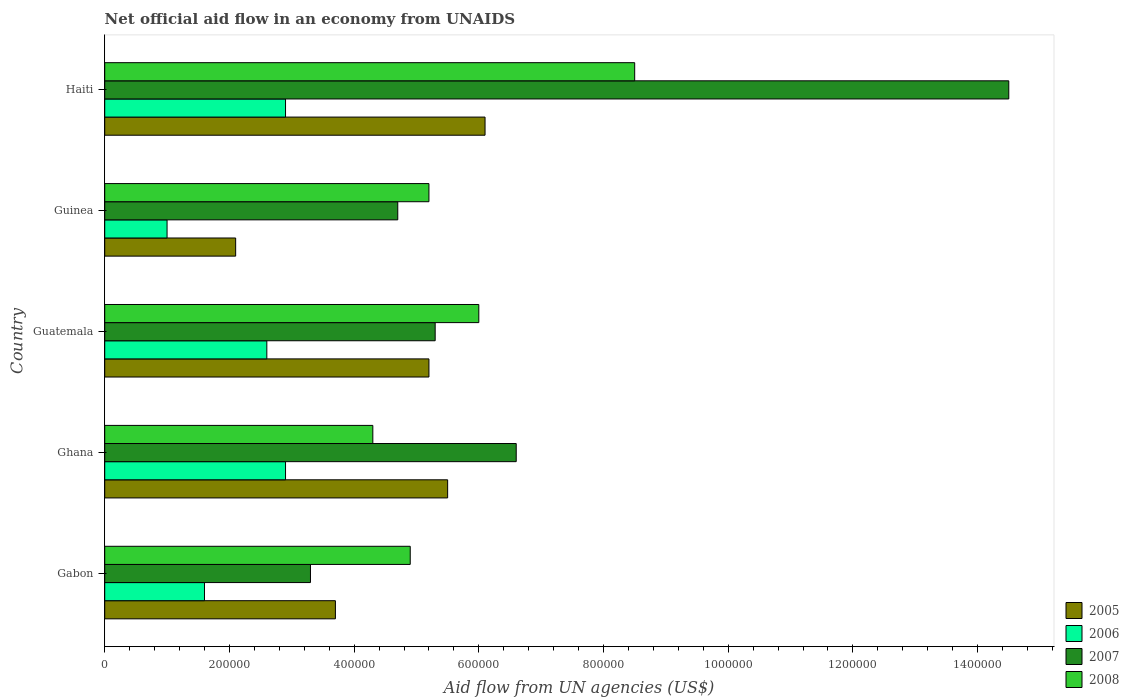Are the number of bars per tick equal to the number of legend labels?
Give a very brief answer. Yes. Are the number of bars on each tick of the Y-axis equal?
Make the answer very short. Yes. How many bars are there on the 4th tick from the bottom?
Your answer should be compact. 4. Across all countries, what is the maximum net official aid flow in 2008?
Give a very brief answer. 8.50e+05. In which country was the net official aid flow in 2005 maximum?
Provide a succinct answer. Haiti. In which country was the net official aid flow in 2006 minimum?
Your answer should be compact. Guinea. What is the total net official aid flow in 2007 in the graph?
Your response must be concise. 3.44e+06. What is the average net official aid flow in 2008 per country?
Give a very brief answer. 5.78e+05. What is the difference between the net official aid flow in 2008 and net official aid flow in 2007 in Haiti?
Your answer should be compact. -6.00e+05. What is the ratio of the net official aid flow in 2008 in Gabon to that in Guatemala?
Provide a short and direct response. 0.82. What is the difference between the highest and the second highest net official aid flow in 2008?
Your answer should be very brief. 2.50e+05. What is the difference between the highest and the lowest net official aid flow in 2006?
Your answer should be compact. 1.90e+05. In how many countries, is the net official aid flow in 2005 greater than the average net official aid flow in 2005 taken over all countries?
Offer a terse response. 3. Is the sum of the net official aid flow in 2005 in Ghana and Guinea greater than the maximum net official aid flow in 2006 across all countries?
Offer a very short reply. Yes. Is it the case that in every country, the sum of the net official aid flow in 2005 and net official aid flow in 2007 is greater than the sum of net official aid flow in 2008 and net official aid flow in 2006?
Offer a terse response. No. What does the 2nd bar from the top in Haiti represents?
Provide a succinct answer. 2007. Is it the case that in every country, the sum of the net official aid flow in 2007 and net official aid flow in 2005 is greater than the net official aid flow in 2008?
Give a very brief answer. Yes. How many bars are there?
Give a very brief answer. 20. Are all the bars in the graph horizontal?
Your response must be concise. Yes. How many countries are there in the graph?
Provide a succinct answer. 5. What is the difference between two consecutive major ticks on the X-axis?
Give a very brief answer. 2.00e+05. Where does the legend appear in the graph?
Your response must be concise. Bottom right. What is the title of the graph?
Make the answer very short. Net official aid flow in an economy from UNAIDS. What is the label or title of the X-axis?
Your response must be concise. Aid flow from UN agencies (US$). What is the Aid flow from UN agencies (US$) in 2005 in Gabon?
Your response must be concise. 3.70e+05. What is the Aid flow from UN agencies (US$) of 2006 in Gabon?
Provide a succinct answer. 1.60e+05. What is the Aid flow from UN agencies (US$) of 2008 in Gabon?
Offer a very short reply. 4.90e+05. What is the Aid flow from UN agencies (US$) in 2005 in Guatemala?
Give a very brief answer. 5.20e+05. What is the Aid flow from UN agencies (US$) in 2007 in Guatemala?
Your answer should be very brief. 5.30e+05. What is the Aid flow from UN agencies (US$) of 2008 in Guatemala?
Give a very brief answer. 6.00e+05. What is the Aid flow from UN agencies (US$) of 2008 in Guinea?
Provide a short and direct response. 5.20e+05. What is the Aid flow from UN agencies (US$) of 2006 in Haiti?
Provide a succinct answer. 2.90e+05. What is the Aid flow from UN agencies (US$) in 2007 in Haiti?
Keep it short and to the point. 1.45e+06. What is the Aid flow from UN agencies (US$) of 2008 in Haiti?
Offer a terse response. 8.50e+05. Across all countries, what is the maximum Aid flow from UN agencies (US$) of 2005?
Provide a succinct answer. 6.10e+05. Across all countries, what is the maximum Aid flow from UN agencies (US$) of 2006?
Your answer should be very brief. 2.90e+05. Across all countries, what is the maximum Aid flow from UN agencies (US$) in 2007?
Your answer should be very brief. 1.45e+06. Across all countries, what is the maximum Aid flow from UN agencies (US$) in 2008?
Your answer should be very brief. 8.50e+05. Across all countries, what is the minimum Aid flow from UN agencies (US$) of 2006?
Provide a succinct answer. 1.00e+05. Across all countries, what is the minimum Aid flow from UN agencies (US$) in 2007?
Offer a terse response. 3.30e+05. What is the total Aid flow from UN agencies (US$) of 2005 in the graph?
Make the answer very short. 2.26e+06. What is the total Aid flow from UN agencies (US$) in 2006 in the graph?
Provide a short and direct response. 1.10e+06. What is the total Aid flow from UN agencies (US$) of 2007 in the graph?
Give a very brief answer. 3.44e+06. What is the total Aid flow from UN agencies (US$) of 2008 in the graph?
Your answer should be very brief. 2.89e+06. What is the difference between the Aid flow from UN agencies (US$) in 2005 in Gabon and that in Ghana?
Offer a terse response. -1.80e+05. What is the difference between the Aid flow from UN agencies (US$) in 2006 in Gabon and that in Ghana?
Keep it short and to the point. -1.30e+05. What is the difference between the Aid flow from UN agencies (US$) of 2007 in Gabon and that in Ghana?
Ensure brevity in your answer.  -3.30e+05. What is the difference between the Aid flow from UN agencies (US$) in 2006 in Gabon and that in Guatemala?
Provide a short and direct response. -1.00e+05. What is the difference between the Aid flow from UN agencies (US$) in 2007 in Gabon and that in Guatemala?
Give a very brief answer. -2.00e+05. What is the difference between the Aid flow from UN agencies (US$) in 2008 in Gabon and that in Guatemala?
Give a very brief answer. -1.10e+05. What is the difference between the Aid flow from UN agencies (US$) of 2005 in Gabon and that in Haiti?
Give a very brief answer. -2.40e+05. What is the difference between the Aid flow from UN agencies (US$) of 2007 in Gabon and that in Haiti?
Offer a very short reply. -1.12e+06. What is the difference between the Aid flow from UN agencies (US$) in 2008 in Gabon and that in Haiti?
Keep it short and to the point. -3.60e+05. What is the difference between the Aid flow from UN agencies (US$) of 2005 in Ghana and that in Guatemala?
Make the answer very short. 3.00e+04. What is the difference between the Aid flow from UN agencies (US$) in 2007 in Ghana and that in Guatemala?
Your answer should be very brief. 1.30e+05. What is the difference between the Aid flow from UN agencies (US$) in 2005 in Ghana and that in Guinea?
Offer a very short reply. 3.40e+05. What is the difference between the Aid flow from UN agencies (US$) of 2008 in Ghana and that in Guinea?
Your answer should be compact. -9.00e+04. What is the difference between the Aid flow from UN agencies (US$) of 2006 in Ghana and that in Haiti?
Make the answer very short. 0. What is the difference between the Aid flow from UN agencies (US$) in 2007 in Ghana and that in Haiti?
Ensure brevity in your answer.  -7.90e+05. What is the difference between the Aid flow from UN agencies (US$) of 2008 in Ghana and that in Haiti?
Provide a short and direct response. -4.20e+05. What is the difference between the Aid flow from UN agencies (US$) in 2007 in Guatemala and that in Guinea?
Your answer should be compact. 6.00e+04. What is the difference between the Aid flow from UN agencies (US$) of 2007 in Guatemala and that in Haiti?
Offer a terse response. -9.20e+05. What is the difference between the Aid flow from UN agencies (US$) of 2008 in Guatemala and that in Haiti?
Keep it short and to the point. -2.50e+05. What is the difference between the Aid flow from UN agencies (US$) in 2005 in Guinea and that in Haiti?
Make the answer very short. -4.00e+05. What is the difference between the Aid flow from UN agencies (US$) in 2006 in Guinea and that in Haiti?
Ensure brevity in your answer.  -1.90e+05. What is the difference between the Aid flow from UN agencies (US$) of 2007 in Guinea and that in Haiti?
Provide a short and direct response. -9.80e+05. What is the difference between the Aid flow from UN agencies (US$) of 2008 in Guinea and that in Haiti?
Your answer should be compact. -3.30e+05. What is the difference between the Aid flow from UN agencies (US$) of 2006 in Gabon and the Aid flow from UN agencies (US$) of 2007 in Ghana?
Your response must be concise. -5.00e+05. What is the difference between the Aid flow from UN agencies (US$) in 2005 in Gabon and the Aid flow from UN agencies (US$) in 2007 in Guatemala?
Provide a short and direct response. -1.60e+05. What is the difference between the Aid flow from UN agencies (US$) in 2005 in Gabon and the Aid flow from UN agencies (US$) in 2008 in Guatemala?
Your answer should be compact. -2.30e+05. What is the difference between the Aid flow from UN agencies (US$) in 2006 in Gabon and the Aid flow from UN agencies (US$) in 2007 in Guatemala?
Ensure brevity in your answer.  -3.70e+05. What is the difference between the Aid flow from UN agencies (US$) of 2006 in Gabon and the Aid flow from UN agencies (US$) of 2008 in Guatemala?
Offer a terse response. -4.40e+05. What is the difference between the Aid flow from UN agencies (US$) of 2007 in Gabon and the Aid flow from UN agencies (US$) of 2008 in Guatemala?
Ensure brevity in your answer.  -2.70e+05. What is the difference between the Aid flow from UN agencies (US$) of 2005 in Gabon and the Aid flow from UN agencies (US$) of 2006 in Guinea?
Provide a short and direct response. 2.70e+05. What is the difference between the Aid flow from UN agencies (US$) of 2005 in Gabon and the Aid flow from UN agencies (US$) of 2008 in Guinea?
Keep it short and to the point. -1.50e+05. What is the difference between the Aid flow from UN agencies (US$) of 2006 in Gabon and the Aid flow from UN agencies (US$) of 2007 in Guinea?
Provide a short and direct response. -3.10e+05. What is the difference between the Aid flow from UN agencies (US$) in 2006 in Gabon and the Aid flow from UN agencies (US$) in 2008 in Guinea?
Ensure brevity in your answer.  -3.60e+05. What is the difference between the Aid flow from UN agencies (US$) of 2007 in Gabon and the Aid flow from UN agencies (US$) of 2008 in Guinea?
Your answer should be very brief. -1.90e+05. What is the difference between the Aid flow from UN agencies (US$) of 2005 in Gabon and the Aid flow from UN agencies (US$) of 2006 in Haiti?
Make the answer very short. 8.00e+04. What is the difference between the Aid flow from UN agencies (US$) in 2005 in Gabon and the Aid flow from UN agencies (US$) in 2007 in Haiti?
Provide a succinct answer. -1.08e+06. What is the difference between the Aid flow from UN agencies (US$) in 2005 in Gabon and the Aid flow from UN agencies (US$) in 2008 in Haiti?
Your answer should be compact. -4.80e+05. What is the difference between the Aid flow from UN agencies (US$) in 2006 in Gabon and the Aid flow from UN agencies (US$) in 2007 in Haiti?
Make the answer very short. -1.29e+06. What is the difference between the Aid flow from UN agencies (US$) of 2006 in Gabon and the Aid flow from UN agencies (US$) of 2008 in Haiti?
Offer a very short reply. -6.90e+05. What is the difference between the Aid flow from UN agencies (US$) in 2007 in Gabon and the Aid flow from UN agencies (US$) in 2008 in Haiti?
Your answer should be very brief. -5.20e+05. What is the difference between the Aid flow from UN agencies (US$) of 2005 in Ghana and the Aid flow from UN agencies (US$) of 2006 in Guatemala?
Ensure brevity in your answer.  2.90e+05. What is the difference between the Aid flow from UN agencies (US$) in 2006 in Ghana and the Aid flow from UN agencies (US$) in 2007 in Guatemala?
Keep it short and to the point. -2.40e+05. What is the difference between the Aid flow from UN agencies (US$) of 2006 in Ghana and the Aid flow from UN agencies (US$) of 2008 in Guatemala?
Your response must be concise. -3.10e+05. What is the difference between the Aid flow from UN agencies (US$) of 2007 in Ghana and the Aid flow from UN agencies (US$) of 2008 in Guatemala?
Your answer should be compact. 6.00e+04. What is the difference between the Aid flow from UN agencies (US$) of 2005 in Ghana and the Aid flow from UN agencies (US$) of 2006 in Guinea?
Give a very brief answer. 4.50e+05. What is the difference between the Aid flow from UN agencies (US$) of 2005 in Ghana and the Aid flow from UN agencies (US$) of 2007 in Guinea?
Your answer should be compact. 8.00e+04. What is the difference between the Aid flow from UN agencies (US$) in 2006 in Ghana and the Aid flow from UN agencies (US$) in 2008 in Guinea?
Ensure brevity in your answer.  -2.30e+05. What is the difference between the Aid flow from UN agencies (US$) in 2005 in Ghana and the Aid flow from UN agencies (US$) in 2007 in Haiti?
Provide a succinct answer. -9.00e+05. What is the difference between the Aid flow from UN agencies (US$) in 2006 in Ghana and the Aid flow from UN agencies (US$) in 2007 in Haiti?
Offer a very short reply. -1.16e+06. What is the difference between the Aid flow from UN agencies (US$) in 2006 in Ghana and the Aid flow from UN agencies (US$) in 2008 in Haiti?
Provide a short and direct response. -5.60e+05. What is the difference between the Aid flow from UN agencies (US$) in 2007 in Ghana and the Aid flow from UN agencies (US$) in 2008 in Haiti?
Keep it short and to the point. -1.90e+05. What is the difference between the Aid flow from UN agencies (US$) in 2005 in Guatemala and the Aid flow from UN agencies (US$) in 2006 in Guinea?
Provide a short and direct response. 4.20e+05. What is the difference between the Aid flow from UN agencies (US$) of 2005 in Guatemala and the Aid flow from UN agencies (US$) of 2007 in Guinea?
Keep it short and to the point. 5.00e+04. What is the difference between the Aid flow from UN agencies (US$) of 2005 in Guatemala and the Aid flow from UN agencies (US$) of 2007 in Haiti?
Your answer should be compact. -9.30e+05. What is the difference between the Aid flow from UN agencies (US$) in 2005 in Guatemala and the Aid flow from UN agencies (US$) in 2008 in Haiti?
Your response must be concise. -3.30e+05. What is the difference between the Aid flow from UN agencies (US$) of 2006 in Guatemala and the Aid flow from UN agencies (US$) of 2007 in Haiti?
Keep it short and to the point. -1.19e+06. What is the difference between the Aid flow from UN agencies (US$) in 2006 in Guatemala and the Aid flow from UN agencies (US$) in 2008 in Haiti?
Provide a succinct answer. -5.90e+05. What is the difference between the Aid flow from UN agencies (US$) in 2007 in Guatemala and the Aid flow from UN agencies (US$) in 2008 in Haiti?
Provide a short and direct response. -3.20e+05. What is the difference between the Aid flow from UN agencies (US$) of 2005 in Guinea and the Aid flow from UN agencies (US$) of 2007 in Haiti?
Keep it short and to the point. -1.24e+06. What is the difference between the Aid flow from UN agencies (US$) of 2005 in Guinea and the Aid flow from UN agencies (US$) of 2008 in Haiti?
Provide a short and direct response. -6.40e+05. What is the difference between the Aid flow from UN agencies (US$) of 2006 in Guinea and the Aid flow from UN agencies (US$) of 2007 in Haiti?
Provide a short and direct response. -1.35e+06. What is the difference between the Aid flow from UN agencies (US$) of 2006 in Guinea and the Aid flow from UN agencies (US$) of 2008 in Haiti?
Offer a terse response. -7.50e+05. What is the difference between the Aid flow from UN agencies (US$) of 2007 in Guinea and the Aid flow from UN agencies (US$) of 2008 in Haiti?
Offer a very short reply. -3.80e+05. What is the average Aid flow from UN agencies (US$) of 2005 per country?
Keep it short and to the point. 4.52e+05. What is the average Aid flow from UN agencies (US$) in 2007 per country?
Your answer should be very brief. 6.88e+05. What is the average Aid flow from UN agencies (US$) of 2008 per country?
Provide a succinct answer. 5.78e+05. What is the difference between the Aid flow from UN agencies (US$) in 2005 and Aid flow from UN agencies (US$) in 2007 in Gabon?
Offer a terse response. 4.00e+04. What is the difference between the Aid flow from UN agencies (US$) in 2005 and Aid flow from UN agencies (US$) in 2008 in Gabon?
Make the answer very short. -1.20e+05. What is the difference between the Aid flow from UN agencies (US$) in 2006 and Aid flow from UN agencies (US$) in 2007 in Gabon?
Your response must be concise. -1.70e+05. What is the difference between the Aid flow from UN agencies (US$) of 2006 and Aid flow from UN agencies (US$) of 2008 in Gabon?
Offer a terse response. -3.30e+05. What is the difference between the Aid flow from UN agencies (US$) of 2007 and Aid flow from UN agencies (US$) of 2008 in Gabon?
Ensure brevity in your answer.  -1.60e+05. What is the difference between the Aid flow from UN agencies (US$) in 2005 and Aid flow from UN agencies (US$) in 2007 in Ghana?
Give a very brief answer. -1.10e+05. What is the difference between the Aid flow from UN agencies (US$) in 2006 and Aid flow from UN agencies (US$) in 2007 in Ghana?
Make the answer very short. -3.70e+05. What is the difference between the Aid flow from UN agencies (US$) in 2007 and Aid flow from UN agencies (US$) in 2008 in Ghana?
Offer a terse response. 2.30e+05. What is the difference between the Aid flow from UN agencies (US$) of 2005 and Aid flow from UN agencies (US$) of 2008 in Guatemala?
Make the answer very short. -8.00e+04. What is the difference between the Aid flow from UN agencies (US$) in 2007 and Aid flow from UN agencies (US$) in 2008 in Guatemala?
Keep it short and to the point. -7.00e+04. What is the difference between the Aid flow from UN agencies (US$) of 2005 and Aid flow from UN agencies (US$) of 2007 in Guinea?
Provide a succinct answer. -2.60e+05. What is the difference between the Aid flow from UN agencies (US$) in 2005 and Aid flow from UN agencies (US$) in 2008 in Guinea?
Provide a short and direct response. -3.10e+05. What is the difference between the Aid flow from UN agencies (US$) of 2006 and Aid flow from UN agencies (US$) of 2007 in Guinea?
Your response must be concise. -3.70e+05. What is the difference between the Aid flow from UN agencies (US$) in 2006 and Aid flow from UN agencies (US$) in 2008 in Guinea?
Your response must be concise. -4.20e+05. What is the difference between the Aid flow from UN agencies (US$) in 2007 and Aid flow from UN agencies (US$) in 2008 in Guinea?
Offer a terse response. -5.00e+04. What is the difference between the Aid flow from UN agencies (US$) in 2005 and Aid flow from UN agencies (US$) in 2007 in Haiti?
Provide a succinct answer. -8.40e+05. What is the difference between the Aid flow from UN agencies (US$) of 2005 and Aid flow from UN agencies (US$) of 2008 in Haiti?
Your answer should be compact. -2.40e+05. What is the difference between the Aid flow from UN agencies (US$) of 2006 and Aid flow from UN agencies (US$) of 2007 in Haiti?
Ensure brevity in your answer.  -1.16e+06. What is the difference between the Aid flow from UN agencies (US$) of 2006 and Aid flow from UN agencies (US$) of 2008 in Haiti?
Your answer should be compact. -5.60e+05. What is the ratio of the Aid flow from UN agencies (US$) in 2005 in Gabon to that in Ghana?
Your answer should be very brief. 0.67. What is the ratio of the Aid flow from UN agencies (US$) in 2006 in Gabon to that in Ghana?
Offer a terse response. 0.55. What is the ratio of the Aid flow from UN agencies (US$) of 2007 in Gabon to that in Ghana?
Offer a very short reply. 0.5. What is the ratio of the Aid flow from UN agencies (US$) in 2008 in Gabon to that in Ghana?
Ensure brevity in your answer.  1.14. What is the ratio of the Aid flow from UN agencies (US$) in 2005 in Gabon to that in Guatemala?
Make the answer very short. 0.71. What is the ratio of the Aid flow from UN agencies (US$) of 2006 in Gabon to that in Guatemala?
Offer a very short reply. 0.62. What is the ratio of the Aid flow from UN agencies (US$) in 2007 in Gabon to that in Guatemala?
Give a very brief answer. 0.62. What is the ratio of the Aid flow from UN agencies (US$) in 2008 in Gabon to that in Guatemala?
Provide a short and direct response. 0.82. What is the ratio of the Aid flow from UN agencies (US$) of 2005 in Gabon to that in Guinea?
Give a very brief answer. 1.76. What is the ratio of the Aid flow from UN agencies (US$) of 2006 in Gabon to that in Guinea?
Your response must be concise. 1.6. What is the ratio of the Aid flow from UN agencies (US$) in 2007 in Gabon to that in Guinea?
Offer a terse response. 0.7. What is the ratio of the Aid flow from UN agencies (US$) of 2008 in Gabon to that in Guinea?
Your answer should be very brief. 0.94. What is the ratio of the Aid flow from UN agencies (US$) in 2005 in Gabon to that in Haiti?
Offer a terse response. 0.61. What is the ratio of the Aid flow from UN agencies (US$) of 2006 in Gabon to that in Haiti?
Provide a short and direct response. 0.55. What is the ratio of the Aid flow from UN agencies (US$) in 2007 in Gabon to that in Haiti?
Provide a succinct answer. 0.23. What is the ratio of the Aid flow from UN agencies (US$) in 2008 in Gabon to that in Haiti?
Provide a succinct answer. 0.58. What is the ratio of the Aid flow from UN agencies (US$) in 2005 in Ghana to that in Guatemala?
Give a very brief answer. 1.06. What is the ratio of the Aid flow from UN agencies (US$) of 2006 in Ghana to that in Guatemala?
Your answer should be very brief. 1.12. What is the ratio of the Aid flow from UN agencies (US$) in 2007 in Ghana to that in Guatemala?
Ensure brevity in your answer.  1.25. What is the ratio of the Aid flow from UN agencies (US$) in 2008 in Ghana to that in Guatemala?
Offer a very short reply. 0.72. What is the ratio of the Aid flow from UN agencies (US$) of 2005 in Ghana to that in Guinea?
Your answer should be very brief. 2.62. What is the ratio of the Aid flow from UN agencies (US$) in 2006 in Ghana to that in Guinea?
Give a very brief answer. 2.9. What is the ratio of the Aid flow from UN agencies (US$) of 2007 in Ghana to that in Guinea?
Give a very brief answer. 1.4. What is the ratio of the Aid flow from UN agencies (US$) of 2008 in Ghana to that in Guinea?
Offer a very short reply. 0.83. What is the ratio of the Aid flow from UN agencies (US$) of 2005 in Ghana to that in Haiti?
Make the answer very short. 0.9. What is the ratio of the Aid flow from UN agencies (US$) in 2007 in Ghana to that in Haiti?
Offer a terse response. 0.46. What is the ratio of the Aid flow from UN agencies (US$) of 2008 in Ghana to that in Haiti?
Offer a terse response. 0.51. What is the ratio of the Aid flow from UN agencies (US$) of 2005 in Guatemala to that in Guinea?
Offer a very short reply. 2.48. What is the ratio of the Aid flow from UN agencies (US$) in 2006 in Guatemala to that in Guinea?
Provide a succinct answer. 2.6. What is the ratio of the Aid flow from UN agencies (US$) in 2007 in Guatemala to that in Guinea?
Give a very brief answer. 1.13. What is the ratio of the Aid flow from UN agencies (US$) of 2008 in Guatemala to that in Guinea?
Keep it short and to the point. 1.15. What is the ratio of the Aid flow from UN agencies (US$) in 2005 in Guatemala to that in Haiti?
Provide a short and direct response. 0.85. What is the ratio of the Aid flow from UN agencies (US$) in 2006 in Guatemala to that in Haiti?
Provide a short and direct response. 0.9. What is the ratio of the Aid flow from UN agencies (US$) of 2007 in Guatemala to that in Haiti?
Offer a very short reply. 0.37. What is the ratio of the Aid flow from UN agencies (US$) in 2008 in Guatemala to that in Haiti?
Your answer should be very brief. 0.71. What is the ratio of the Aid flow from UN agencies (US$) of 2005 in Guinea to that in Haiti?
Provide a short and direct response. 0.34. What is the ratio of the Aid flow from UN agencies (US$) of 2006 in Guinea to that in Haiti?
Your response must be concise. 0.34. What is the ratio of the Aid flow from UN agencies (US$) of 2007 in Guinea to that in Haiti?
Make the answer very short. 0.32. What is the ratio of the Aid flow from UN agencies (US$) in 2008 in Guinea to that in Haiti?
Give a very brief answer. 0.61. What is the difference between the highest and the second highest Aid flow from UN agencies (US$) in 2005?
Your answer should be compact. 6.00e+04. What is the difference between the highest and the second highest Aid flow from UN agencies (US$) in 2007?
Your answer should be very brief. 7.90e+05. What is the difference between the highest and the second highest Aid flow from UN agencies (US$) in 2008?
Your response must be concise. 2.50e+05. What is the difference between the highest and the lowest Aid flow from UN agencies (US$) in 2007?
Make the answer very short. 1.12e+06. 